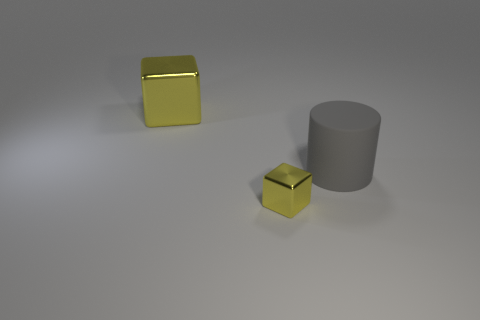How many other objects are the same color as the big metallic thing?
Your answer should be very brief. 1. What is the size of the other yellow object that is the same material as the big yellow object?
Provide a short and direct response. Small. What number of blue things are either big cubes or small things?
Your answer should be compact. 0. There is a yellow block in front of the cylinder; what number of large gray things are right of it?
Offer a terse response. 1. Is the number of tiny yellow metallic blocks on the left side of the tiny block greater than the number of gray rubber cylinders left of the rubber cylinder?
Provide a succinct answer. No. What is the small cube made of?
Your response must be concise. Metal. Are there any yellow shiny blocks that have the same size as the rubber cylinder?
Keep it short and to the point. Yes. What material is the yellow object that is the same size as the gray cylinder?
Your answer should be compact. Metal. How many tiny red objects are there?
Ensure brevity in your answer.  0. How big is the yellow thing that is behind the big gray matte thing?
Provide a succinct answer. Large. 